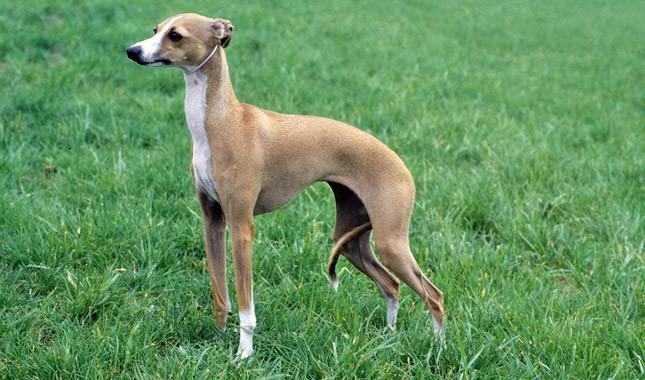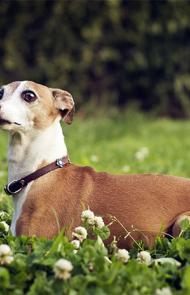The first image is the image on the left, the second image is the image on the right. For the images shown, is this caption "In all photos, all four legs are visible." true? Answer yes or no. No. 